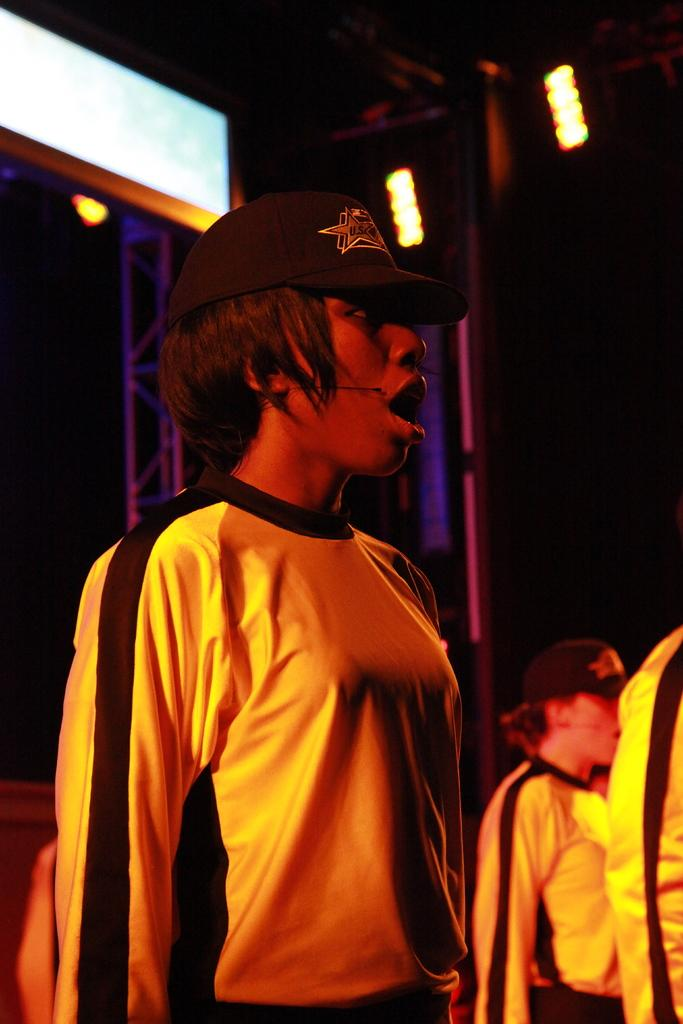Who or what is present in the image? There are people in the image. What are the people wearing on their upper bodies? The people are wearing yellow t-shirts. What are the people wearing on their heads? The people are wearing black caps. What can be seen at the top of the image? There are lights visible at the top of the image. What type of leather is being used to make the wren's nest in the image? There is no wren or nest present in the image, so it is not possible to determine what type of leather might be used. 